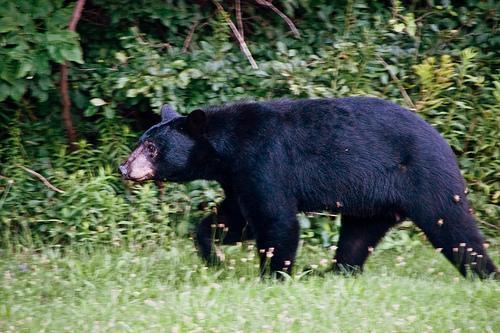How many bears are there?
Give a very brief answer. 1. 